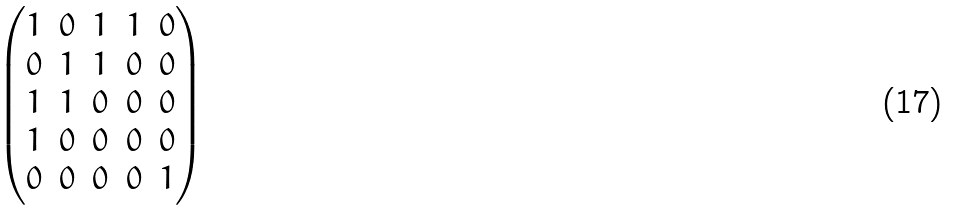Convert formula to latex. <formula><loc_0><loc_0><loc_500><loc_500>\begin{pmatrix} 1 & 0 & 1 & 1 & 0 \\ 0 & 1 & 1 & 0 & 0 \\ 1 & 1 & 0 & 0 & 0 \\ 1 & 0 & 0 & 0 & 0 \\ 0 & 0 & 0 & 0 & 1 \end{pmatrix}</formula> 